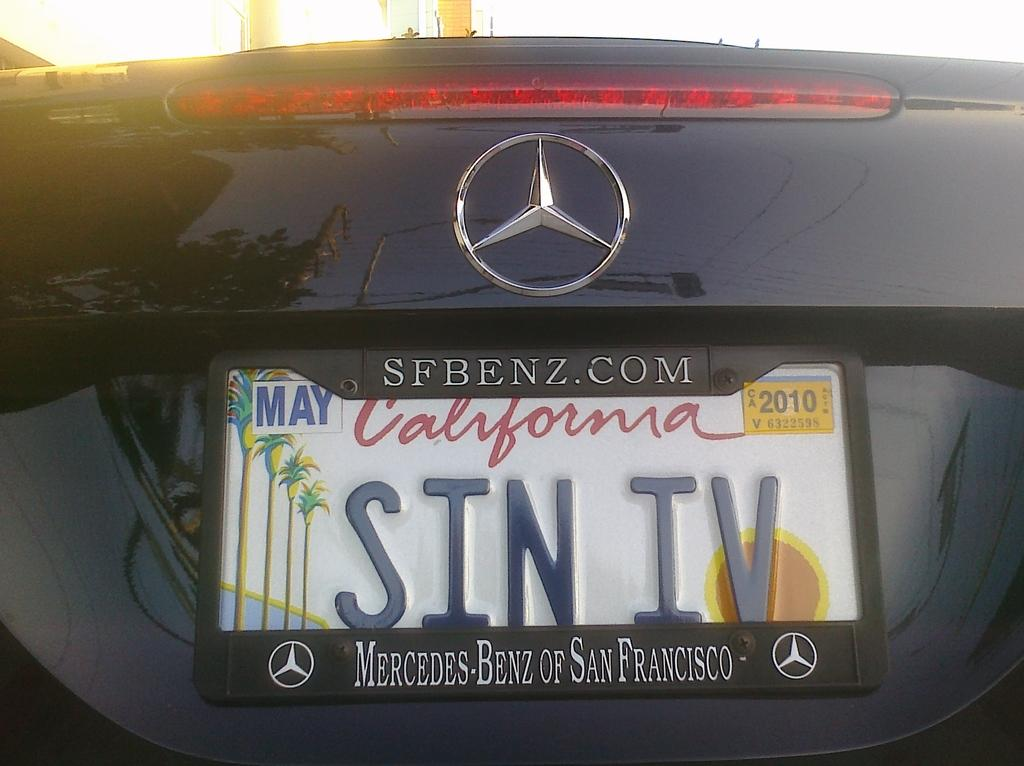Provide a one-sentence caption for the provided image. A mercedes benz branded back bumper with a license plate for california on it. 